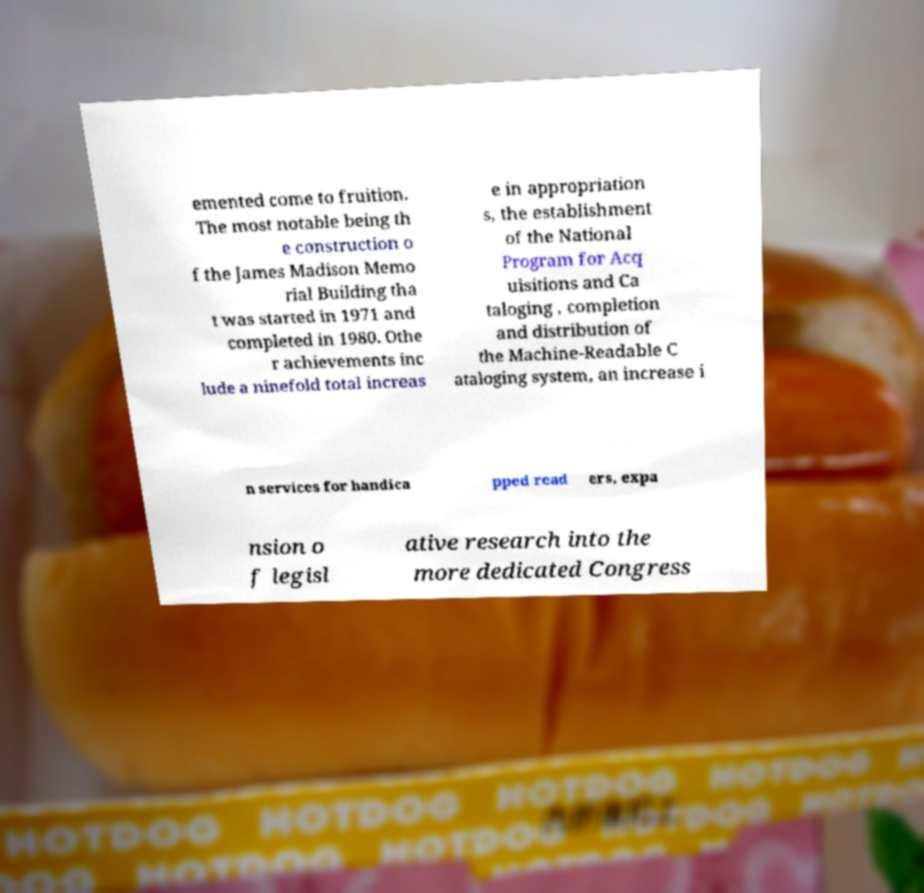Can you accurately transcribe the text from the provided image for me? emented come to fruition. The most notable being th e construction o f the James Madison Memo rial Building tha t was started in 1971 and completed in 1980. Othe r achievements inc lude a ninefold total increas e in appropriation s, the establishment of the National Program for Acq uisitions and Ca taloging , completion and distribution of the Machine-Readable C ataloging system, an increase i n services for handica pped read ers, expa nsion o f legisl ative research into the more dedicated Congress 